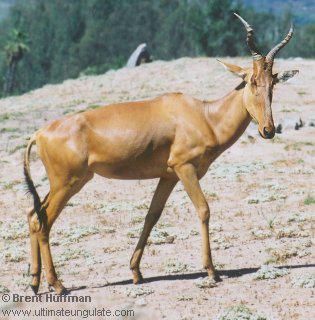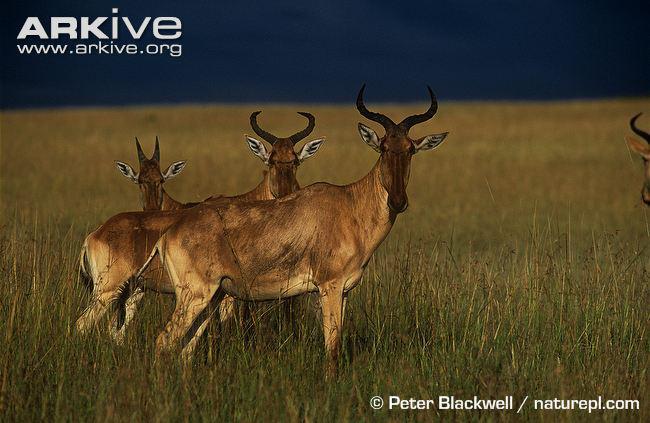The first image is the image on the left, the second image is the image on the right. For the images displayed, is the sentence "One image contains two upright horned animals engaged in physical contact, and the other image contains one horned animal standing in profile." factually correct? Answer yes or no. No. The first image is the image on the left, the second image is the image on the right. Analyze the images presented: Is the assertion "There are exactly three goats." valid? Answer yes or no. No. 